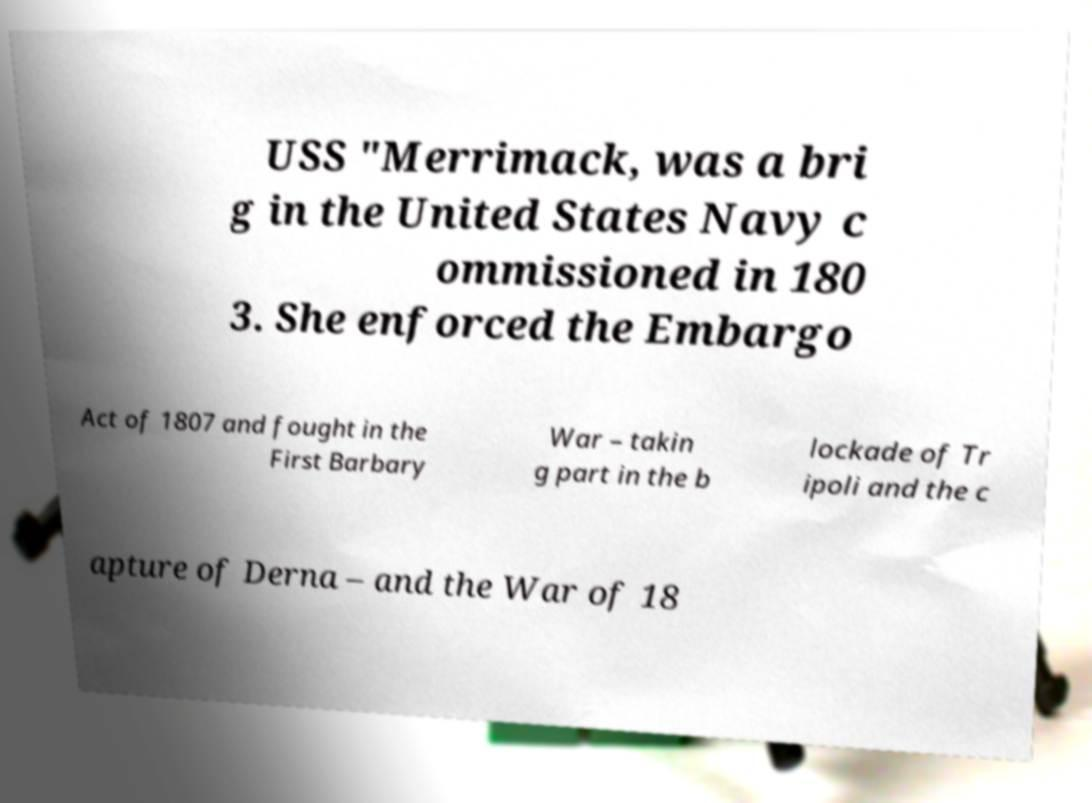There's text embedded in this image that I need extracted. Can you transcribe it verbatim? USS "Merrimack, was a bri g in the United States Navy c ommissioned in 180 3. She enforced the Embargo Act of 1807 and fought in the First Barbary War – takin g part in the b lockade of Tr ipoli and the c apture of Derna – and the War of 18 